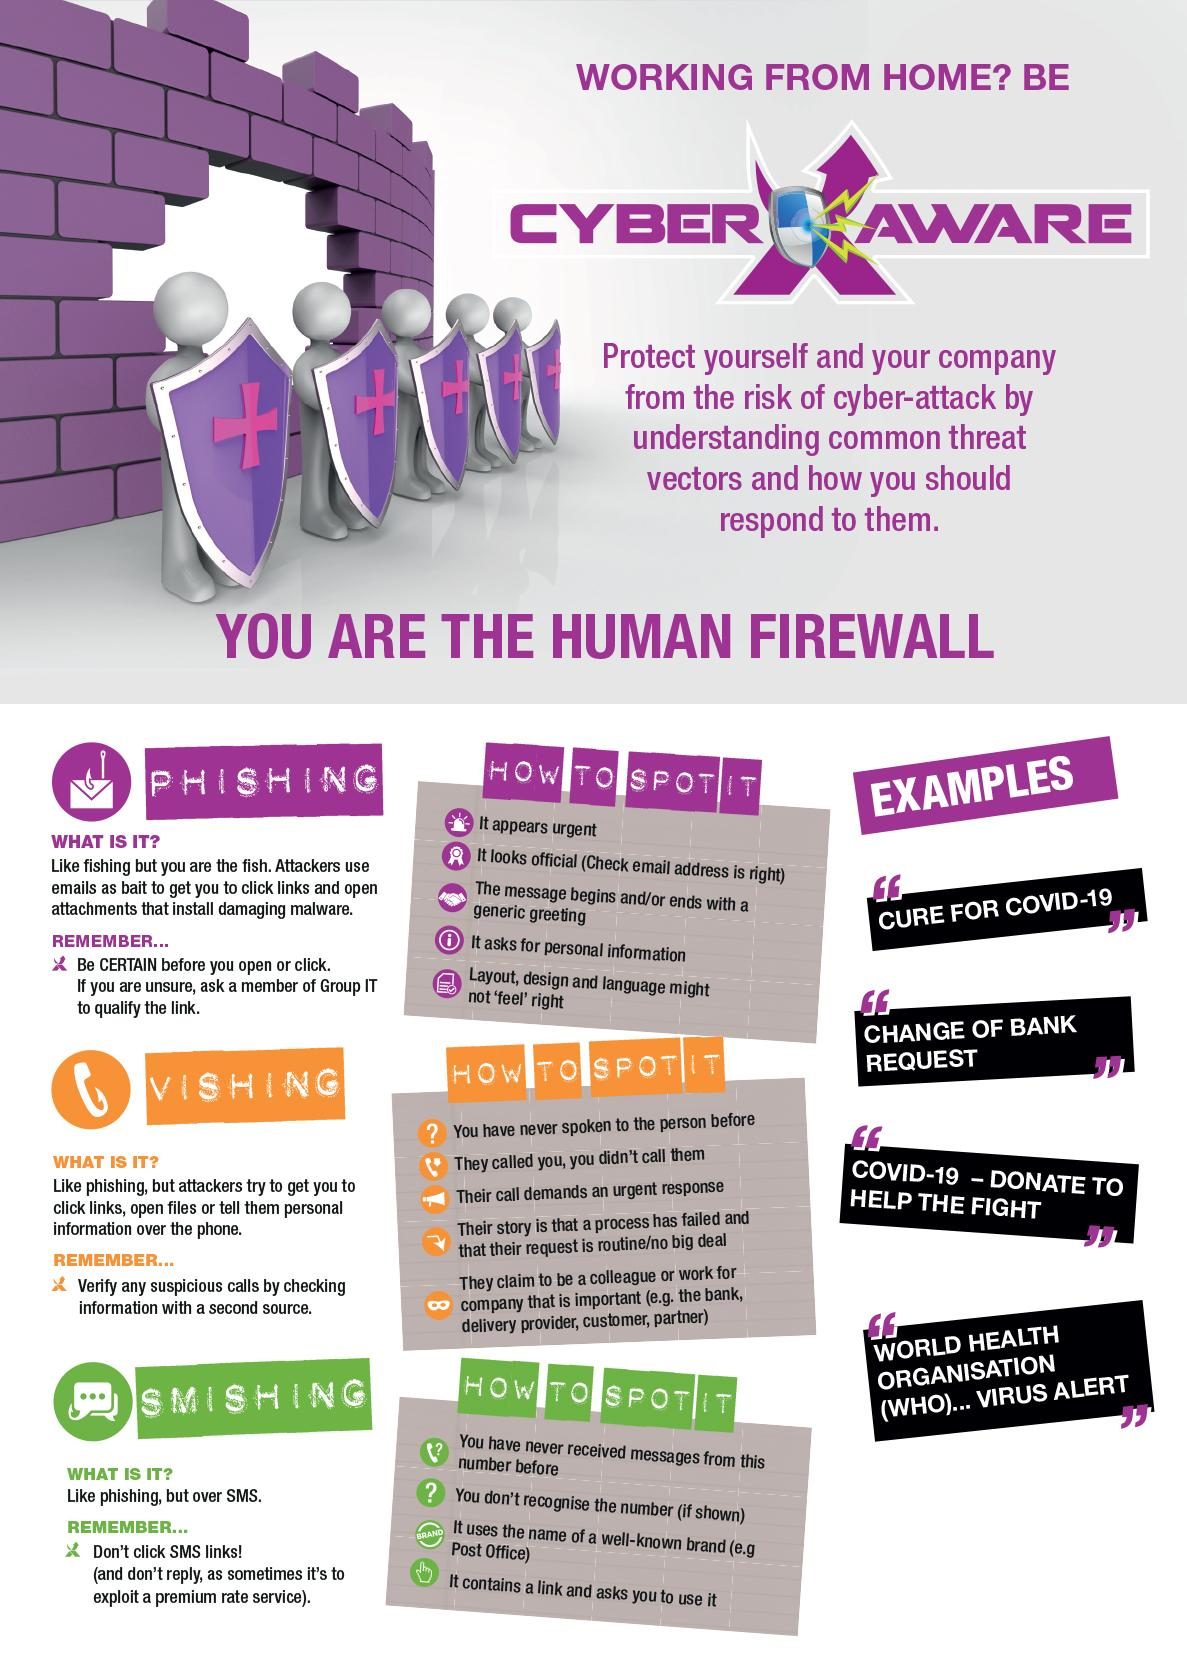Outline some significant characteristics in this image. The infographics list five ways to spot Vishing. There are five ways that infographics have listed to spot phishing. Phishing via SMS is known as Smishing. There are four ways listed in the infographics to spot smishing. 